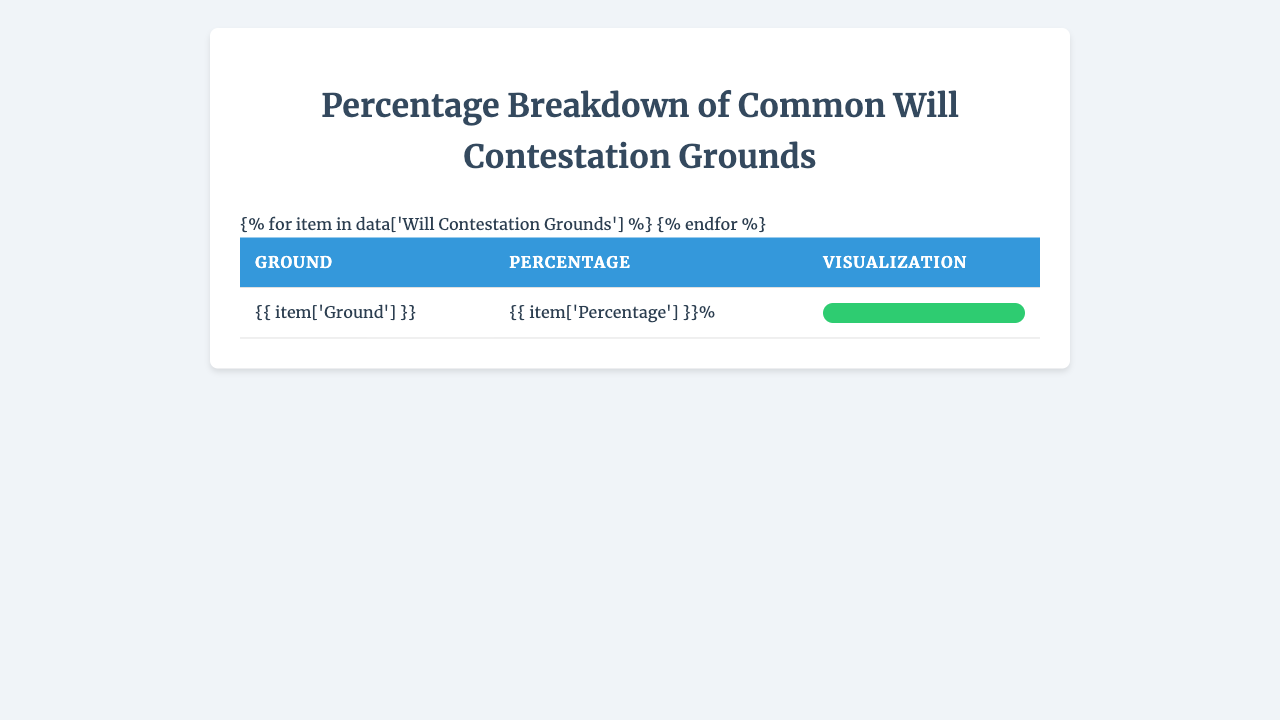What is the ground for will contestation with the highest percentage? By examining the table, the highest percentage is associated with "Lack of Testamentary Capacity," which has a percentage of 35%.
Answer: 35% What percentage of will contestations are based on undue influence? The table shows that "Undue Influence" accounts for 28% of will contestation grounds.
Answer: 28% If you sum the percentages of fraud and improper execution, what do you get? "Fraud" has a percentage of 12% and "Improper Execution" has a percentage of 15%. Adding these together gives 12 + 15 = 27.
Answer: 27% Is there a ground for will contestation listed with a percentage of 1%? Yes, both "Duress" and "Other" are listed with a percentage of 1%.
Answer: Yes What percentage of will contestation grounds are attributed to fraud and revocation combined? "Fraud" accounts for 12% and "Revocation" accounts for 5%; adding them gives 12 + 5 = 17%.
Answer: 17% Which type of contestation ground has the least percentage? The types with the least percentage are "Forgery," "Duress," and "Other," each with 1%.
Answer: 1% How does the percentage for improper execution compare to that of forgery? "Improper Execution" has a percentage of 15% while "Forgery" has 3%. Comparing these, 15% is greater than 3%.
Answer: Greater What is the total percentage accounted for by the top three grounds? The top three grounds are "Lack of Testamentary Capacity" (35%), "Undue Influence" (28%), and "Improper Execution" (15). Summing these gives 35 + 28 + 15 = 78%.
Answer: 78% If we remove "Revocation" and "Forgery," what is the total percentage of the remaining grounds? Removing "Revocation" (5%) and "Forgery" (3%) from the total (100%), we sum the remaining percentages: 35 (Lack of Testamentary Capacity) + 28 (Undue Influence) + 15 (Improper Execution) + 12 (Fraud) + 1 (Duress) + 1 (Other) = 92%.
Answer: 92% 